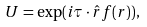Convert formula to latex. <formula><loc_0><loc_0><loc_500><loc_500>U = \exp ( i { \tau } \cdot \hat { r } f ( r ) ) ,</formula> 